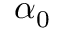<formula> <loc_0><loc_0><loc_500><loc_500>\alpha _ { 0 }</formula> 